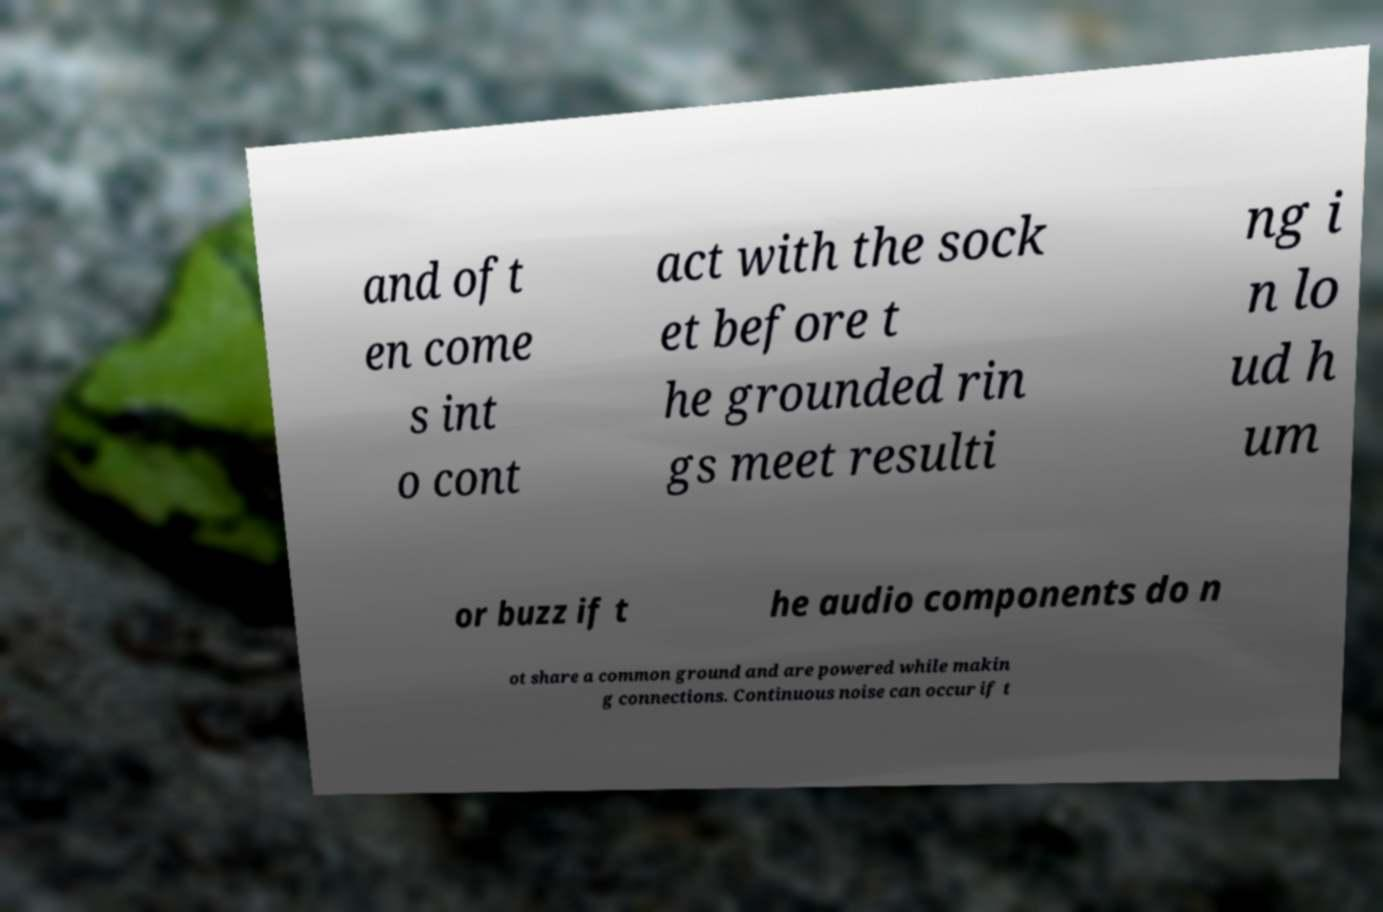Please read and relay the text visible in this image. What does it say? and oft en come s int o cont act with the sock et before t he grounded rin gs meet resulti ng i n lo ud h um or buzz if t he audio components do n ot share a common ground and are powered while makin g connections. Continuous noise can occur if t 